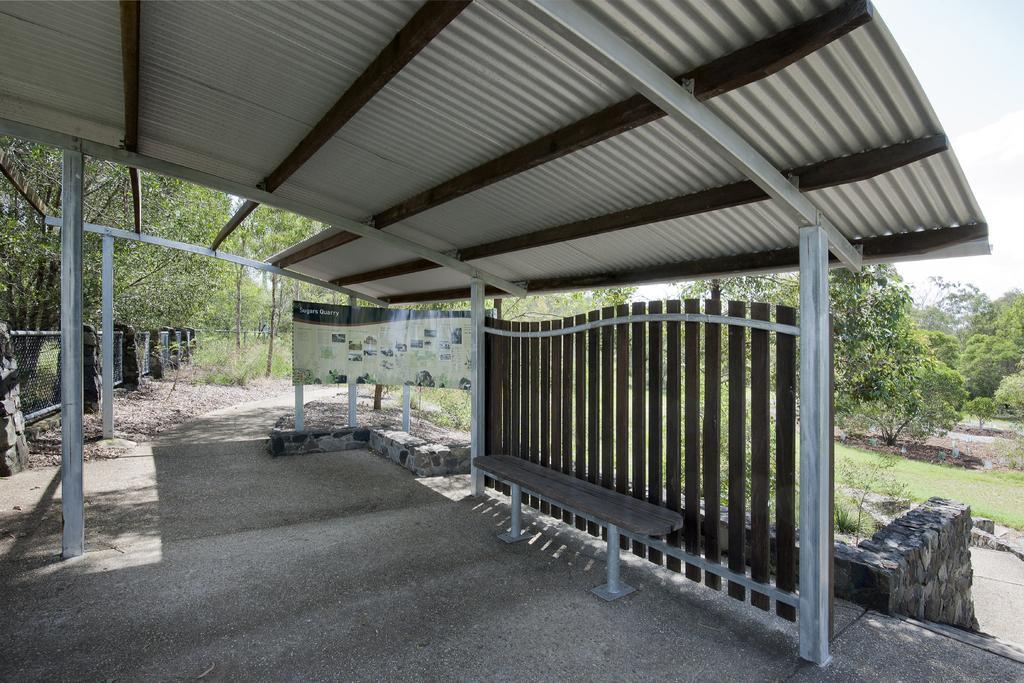How would you summarize this image in a sentence or two? In this picture we can see a bench on the ground, shelter, fences, boards, plants, wall, trees and some objects and in the background we can see the sky. 